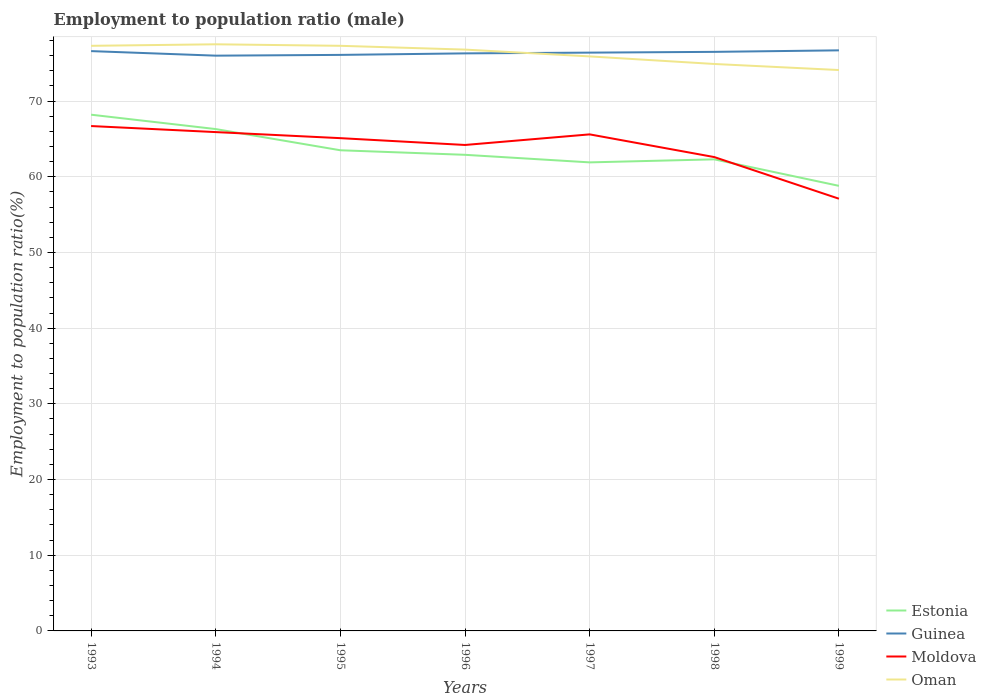Across all years, what is the maximum employment to population ratio in Oman?
Your answer should be compact. 74.1. What is the total employment to population ratio in Moldova in the graph?
Provide a short and direct response. 7.1. What is the difference between the highest and the second highest employment to population ratio in Guinea?
Your answer should be compact. 0.7. What is the difference between the highest and the lowest employment to population ratio in Oman?
Ensure brevity in your answer.  4. How many years are there in the graph?
Your response must be concise. 7. Where does the legend appear in the graph?
Your answer should be compact. Bottom right. How many legend labels are there?
Offer a terse response. 4. What is the title of the graph?
Your answer should be compact. Employment to population ratio (male). Does "Latvia" appear as one of the legend labels in the graph?
Give a very brief answer. No. What is the Employment to population ratio(%) in Estonia in 1993?
Provide a succinct answer. 68.2. What is the Employment to population ratio(%) of Guinea in 1993?
Your response must be concise. 76.6. What is the Employment to population ratio(%) of Moldova in 1993?
Give a very brief answer. 66.7. What is the Employment to population ratio(%) in Oman in 1993?
Offer a terse response. 77.3. What is the Employment to population ratio(%) in Estonia in 1994?
Ensure brevity in your answer.  66.3. What is the Employment to population ratio(%) of Moldova in 1994?
Provide a short and direct response. 65.9. What is the Employment to population ratio(%) of Oman in 1994?
Offer a very short reply. 77.5. What is the Employment to population ratio(%) of Estonia in 1995?
Make the answer very short. 63.5. What is the Employment to population ratio(%) in Guinea in 1995?
Provide a succinct answer. 76.1. What is the Employment to population ratio(%) of Moldova in 1995?
Give a very brief answer. 65.1. What is the Employment to population ratio(%) in Oman in 1995?
Give a very brief answer. 77.3. What is the Employment to population ratio(%) of Estonia in 1996?
Make the answer very short. 62.9. What is the Employment to population ratio(%) of Guinea in 1996?
Make the answer very short. 76.3. What is the Employment to population ratio(%) of Moldova in 1996?
Your answer should be very brief. 64.2. What is the Employment to population ratio(%) in Oman in 1996?
Your response must be concise. 76.8. What is the Employment to population ratio(%) of Estonia in 1997?
Keep it short and to the point. 61.9. What is the Employment to population ratio(%) of Guinea in 1997?
Your response must be concise. 76.4. What is the Employment to population ratio(%) in Moldova in 1997?
Give a very brief answer. 65.6. What is the Employment to population ratio(%) of Oman in 1997?
Your response must be concise. 75.9. What is the Employment to population ratio(%) of Estonia in 1998?
Offer a very short reply. 62.3. What is the Employment to population ratio(%) of Guinea in 1998?
Give a very brief answer. 76.5. What is the Employment to population ratio(%) in Moldova in 1998?
Your response must be concise. 62.6. What is the Employment to population ratio(%) in Oman in 1998?
Ensure brevity in your answer.  74.9. What is the Employment to population ratio(%) of Estonia in 1999?
Make the answer very short. 58.8. What is the Employment to population ratio(%) of Guinea in 1999?
Offer a very short reply. 76.7. What is the Employment to population ratio(%) of Moldova in 1999?
Keep it short and to the point. 57.1. What is the Employment to population ratio(%) of Oman in 1999?
Offer a terse response. 74.1. Across all years, what is the maximum Employment to population ratio(%) in Estonia?
Keep it short and to the point. 68.2. Across all years, what is the maximum Employment to population ratio(%) in Guinea?
Provide a succinct answer. 76.7. Across all years, what is the maximum Employment to population ratio(%) of Moldova?
Make the answer very short. 66.7. Across all years, what is the maximum Employment to population ratio(%) in Oman?
Keep it short and to the point. 77.5. Across all years, what is the minimum Employment to population ratio(%) of Estonia?
Offer a very short reply. 58.8. Across all years, what is the minimum Employment to population ratio(%) in Guinea?
Offer a very short reply. 76. Across all years, what is the minimum Employment to population ratio(%) of Moldova?
Make the answer very short. 57.1. Across all years, what is the minimum Employment to population ratio(%) in Oman?
Your answer should be very brief. 74.1. What is the total Employment to population ratio(%) in Estonia in the graph?
Make the answer very short. 443.9. What is the total Employment to population ratio(%) in Guinea in the graph?
Offer a very short reply. 534.6. What is the total Employment to population ratio(%) in Moldova in the graph?
Ensure brevity in your answer.  447.2. What is the total Employment to population ratio(%) of Oman in the graph?
Offer a terse response. 533.8. What is the difference between the Employment to population ratio(%) in Guinea in 1993 and that in 1994?
Offer a very short reply. 0.6. What is the difference between the Employment to population ratio(%) of Estonia in 1993 and that in 1995?
Provide a succinct answer. 4.7. What is the difference between the Employment to population ratio(%) in Moldova in 1993 and that in 1995?
Offer a very short reply. 1.6. What is the difference between the Employment to population ratio(%) in Guinea in 1993 and that in 1996?
Your answer should be compact. 0.3. What is the difference between the Employment to population ratio(%) of Oman in 1993 and that in 1997?
Your answer should be very brief. 1.4. What is the difference between the Employment to population ratio(%) of Guinea in 1993 and that in 1998?
Your response must be concise. 0.1. What is the difference between the Employment to population ratio(%) of Guinea in 1993 and that in 1999?
Your response must be concise. -0.1. What is the difference between the Employment to population ratio(%) in Moldova in 1993 and that in 1999?
Offer a terse response. 9.6. What is the difference between the Employment to population ratio(%) in Oman in 1993 and that in 1999?
Offer a terse response. 3.2. What is the difference between the Employment to population ratio(%) in Guinea in 1994 and that in 1995?
Provide a short and direct response. -0.1. What is the difference between the Employment to population ratio(%) of Estonia in 1994 and that in 1996?
Keep it short and to the point. 3.4. What is the difference between the Employment to population ratio(%) in Guinea in 1994 and that in 1996?
Offer a terse response. -0.3. What is the difference between the Employment to population ratio(%) in Estonia in 1994 and that in 1997?
Your answer should be compact. 4.4. What is the difference between the Employment to population ratio(%) in Guinea in 1994 and that in 1998?
Your answer should be very brief. -0.5. What is the difference between the Employment to population ratio(%) in Oman in 1994 and that in 1998?
Your response must be concise. 2.6. What is the difference between the Employment to population ratio(%) of Estonia in 1994 and that in 1999?
Keep it short and to the point. 7.5. What is the difference between the Employment to population ratio(%) of Guinea in 1994 and that in 1999?
Ensure brevity in your answer.  -0.7. What is the difference between the Employment to population ratio(%) of Oman in 1994 and that in 1999?
Keep it short and to the point. 3.4. What is the difference between the Employment to population ratio(%) of Oman in 1995 and that in 1996?
Your response must be concise. 0.5. What is the difference between the Employment to population ratio(%) of Estonia in 1995 and that in 1997?
Keep it short and to the point. 1.6. What is the difference between the Employment to population ratio(%) in Oman in 1995 and that in 1998?
Your response must be concise. 2.4. What is the difference between the Employment to population ratio(%) in Oman in 1995 and that in 1999?
Provide a succinct answer. 3.2. What is the difference between the Employment to population ratio(%) of Estonia in 1996 and that in 1997?
Make the answer very short. 1. What is the difference between the Employment to population ratio(%) in Moldova in 1996 and that in 1997?
Provide a short and direct response. -1.4. What is the difference between the Employment to population ratio(%) of Oman in 1996 and that in 1997?
Offer a terse response. 0.9. What is the difference between the Employment to population ratio(%) of Guinea in 1996 and that in 1998?
Provide a short and direct response. -0.2. What is the difference between the Employment to population ratio(%) of Moldova in 1996 and that in 1998?
Provide a succinct answer. 1.6. What is the difference between the Employment to population ratio(%) of Estonia in 1996 and that in 1999?
Your answer should be very brief. 4.1. What is the difference between the Employment to population ratio(%) of Moldova in 1996 and that in 1999?
Your answer should be very brief. 7.1. What is the difference between the Employment to population ratio(%) in Oman in 1996 and that in 1999?
Keep it short and to the point. 2.7. What is the difference between the Employment to population ratio(%) of Estonia in 1997 and that in 1998?
Make the answer very short. -0.4. What is the difference between the Employment to population ratio(%) in Guinea in 1997 and that in 1998?
Your answer should be very brief. -0.1. What is the difference between the Employment to population ratio(%) of Guinea in 1997 and that in 1999?
Make the answer very short. -0.3. What is the difference between the Employment to population ratio(%) in Estonia in 1993 and the Employment to population ratio(%) in Oman in 1994?
Provide a succinct answer. -9.3. What is the difference between the Employment to population ratio(%) in Guinea in 1993 and the Employment to population ratio(%) in Oman in 1994?
Offer a terse response. -0.9. What is the difference between the Employment to population ratio(%) in Moldova in 1993 and the Employment to population ratio(%) in Oman in 1994?
Offer a very short reply. -10.8. What is the difference between the Employment to population ratio(%) in Guinea in 1993 and the Employment to population ratio(%) in Moldova in 1995?
Provide a succinct answer. 11.5. What is the difference between the Employment to population ratio(%) of Estonia in 1993 and the Employment to population ratio(%) of Guinea in 1996?
Your answer should be compact. -8.1. What is the difference between the Employment to population ratio(%) of Estonia in 1993 and the Employment to population ratio(%) of Oman in 1996?
Offer a terse response. -8.6. What is the difference between the Employment to population ratio(%) in Estonia in 1993 and the Employment to population ratio(%) in Guinea in 1997?
Provide a succinct answer. -8.2. What is the difference between the Employment to population ratio(%) in Estonia in 1993 and the Employment to population ratio(%) in Moldova in 1997?
Offer a very short reply. 2.6. What is the difference between the Employment to population ratio(%) in Guinea in 1993 and the Employment to population ratio(%) in Moldova in 1997?
Your answer should be very brief. 11. What is the difference between the Employment to population ratio(%) of Guinea in 1993 and the Employment to population ratio(%) of Oman in 1997?
Offer a terse response. 0.7. What is the difference between the Employment to population ratio(%) of Moldova in 1993 and the Employment to population ratio(%) of Oman in 1997?
Your answer should be compact. -9.2. What is the difference between the Employment to population ratio(%) in Estonia in 1993 and the Employment to population ratio(%) in Guinea in 1998?
Provide a succinct answer. -8.3. What is the difference between the Employment to population ratio(%) of Guinea in 1993 and the Employment to population ratio(%) of Oman in 1998?
Make the answer very short. 1.7. What is the difference between the Employment to population ratio(%) in Estonia in 1993 and the Employment to population ratio(%) in Guinea in 1999?
Offer a terse response. -8.5. What is the difference between the Employment to population ratio(%) in Estonia in 1993 and the Employment to population ratio(%) in Oman in 1999?
Offer a very short reply. -5.9. What is the difference between the Employment to population ratio(%) in Guinea in 1993 and the Employment to population ratio(%) in Oman in 1999?
Offer a very short reply. 2.5. What is the difference between the Employment to population ratio(%) of Estonia in 1994 and the Employment to population ratio(%) of Moldova in 1995?
Your response must be concise. 1.2. What is the difference between the Employment to population ratio(%) in Estonia in 1994 and the Employment to population ratio(%) in Oman in 1995?
Provide a succinct answer. -11. What is the difference between the Employment to population ratio(%) of Moldova in 1994 and the Employment to population ratio(%) of Oman in 1995?
Provide a succinct answer. -11.4. What is the difference between the Employment to population ratio(%) in Estonia in 1994 and the Employment to population ratio(%) in Moldova in 1996?
Your answer should be compact. 2.1. What is the difference between the Employment to population ratio(%) of Guinea in 1994 and the Employment to population ratio(%) of Moldova in 1996?
Make the answer very short. 11.8. What is the difference between the Employment to population ratio(%) in Guinea in 1994 and the Employment to population ratio(%) in Oman in 1996?
Make the answer very short. -0.8. What is the difference between the Employment to population ratio(%) of Estonia in 1994 and the Employment to population ratio(%) of Moldova in 1997?
Provide a succinct answer. 0.7. What is the difference between the Employment to population ratio(%) in Guinea in 1994 and the Employment to population ratio(%) in Moldova in 1997?
Provide a short and direct response. 10.4. What is the difference between the Employment to population ratio(%) in Guinea in 1994 and the Employment to population ratio(%) in Oman in 1997?
Provide a short and direct response. 0.1. What is the difference between the Employment to population ratio(%) in Moldova in 1994 and the Employment to population ratio(%) in Oman in 1997?
Offer a terse response. -10. What is the difference between the Employment to population ratio(%) in Estonia in 1994 and the Employment to population ratio(%) in Oman in 1998?
Provide a succinct answer. -8.6. What is the difference between the Employment to population ratio(%) of Guinea in 1994 and the Employment to population ratio(%) of Oman in 1998?
Your answer should be very brief. 1.1. What is the difference between the Employment to population ratio(%) in Moldova in 1994 and the Employment to population ratio(%) in Oman in 1998?
Make the answer very short. -9. What is the difference between the Employment to population ratio(%) in Estonia in 1994 and the Employment to population ratio(%) in Guinea in 1999?
Give a very brief answer. -10.4. What is the difference between the Employment to population ratio(%) of Estonia in 1994 and the Employment to population ratio(%) of Moldova in 1999?
Provide a succinct answer. 9.2. What is the difference between the Employment to population ratio(%) of Estonia in 1994 and the Employment to population ratio(%) of Oman in 1999?
Your answer should be compact. -7.8. What is the difference between the Employment to population ratio(%) in Estonia in 1995 and the Employment to population ratio(%) in Guinea in 1996?
Provide a succinct answer. -12.8. What is the difference between the Employment to population ratio(%) in Guinea in 1995 and the Employment to population ratio(%) in Moldova in 1996?
Your response must be concise. 11.9. What is the difference between the Employment to population ratio(%) of Guinea in 1995 and the Employment to population ratio(%) of Oman in 1996?
Provide a short and direct response. -0.7. What is the difference between the Employment to population ratio(%) in Estonia in 1995 and the Employment to population ratio(%) in Guinea in 1997?
Make the answer very short. -12.9. What is the difference between the Employment to population ratio(%) in Guinea in 1995 and the Employment to population ratio(%) in Oman in 1997?
Offer a very short reply. 0.2. What is the difference between the Employment to population ratio(%) in Moldova in 1995 and the Employment to population ratio(%) in Oman in 1997?
Provide a short and direct response. -10.8. What is the difference between the Employment to population ratio(%) of Estonia in 1995 and the Employment to population ratio(%) of Guinea in 1998?
Your answer should be very brief. -13. What is the difference between the Employment to population ratio(%) in Estonia in 1995 and the Employment to population ratio(%) in Oman in 1998?
Ensure brevity in your answer.  -11.4. What is the difference between the Employment to population ratio(%) in Guinea in 1995 and the Employment to population ratio(%) in Moldova in 1998?
Offer a terse response. 13.5. What is the difference between the Employment to population ratio(%) in Estonia in 1995 and the Employment to population ratio(%) in Guinea in 1999?
Keep it short and to the point. -13.2. What is the difference between the Employment to population ratio(%) of Estonia in 1995 and the Employment to population ratio(%) of Moldova in 1999?
Offer a terse response. 6.4. What is the difference between the Employment to population ratio(%) of Estonia in 1995 and the Employment to population ratio(%) of Oman in 1999?
Keep it short and to the point. -10.6. What is the difference between the Employment to population ratio(%) in Guinea in 1995 and the Employment to population ratio(%) in Oman in 1999?
Your answer should be compact. 2. What is the difference between the Employment to population ratio(%) in Moldova in 1995 and the Employment to population ratio(%) in Oman in 1999?
Make the answer very short. -9. What is the difference between the Employment to population ratio(%) in Estonia in 1996 and the Employment to population ratio(%) in Guinea in 1997?
Keep it short and to the point. -13.5. What is the difference between the Employment to population ratio(%) in Estonia in 1996 and the Employment to population ratio(%) in Oman in 1997?
Your answer should be compact. -13. What is the difference between the Employment to population ratio(%) of Guinea in 1996 and the Employment to population ratio(%) of Moldova in 1997?
Your response must be concise. 10.7. What is the difference between the Employment to population ratio(%) of Estonia in 1996 and the Employment to population ratio(%) of Guinea in 1998?
Keep it short and to the point. -13.6. What is the difference between the Employment to population ratio(%) in Estonia in 1996 and the Employment to population ratio(%) in Moldova in 1998?
Make the answer very short. 0.3. What is the difference between the Employment to population ratio(%) in Estonia in 1996 and the Employment to population ratio(%) in Oman in 1998?
Offer a terse response. -12. What is the difference between the Employment to population ratio(%) of Guinea in 1996 and the Employment to population ratio(%) of Oman in 1998?
Provide a succinct answer. 1.4. What is the difference between the Employment to population ratio(%) of Moldova in 1996 and the Employment to population ratio(%) of Oman in 1998?
Offer a very short reply. -10.7. What is the difference between the Employment to population ratio(%) of Guinea in 1996 and the Employment to population ratio(%) of Oman in 1999?
Your answer should be very brief. 2.2. What is the difference between the Employment to population ratio(%) of Estonia in 1997 and the Employment to population ratio(%) of Guinea in 1998?
Ensure brevity in your answer.  -14.6. What is the difference between the Employment to population ratio(%) of Moldova in 1997 and the Employment to population ratio(%) of Oman in 1998?
Offer a very short reply. -9.3. What is the difference between the Employment to population ratio(%) in Estonia in 1997 and the Employment to population ratio(%) in Guinea in 1999?
Ensure brevity in your answer.  -14.8. What is the difference between the Employment to population ratio(%) of Estonia in 1997 and the Employment to population ratio(%) of Moldova in 1999?
Your answer should be compact. 4.8. What is the difference between the Employment to population ratio(%) of Estonia in 1997 and the Employment to population ratio(%) of Oman in 1999?
Make the answer very short. -12.2. What is the difference between the Employment to population ratio(%) in Guinea in 1997 and the Employment to population ratio(%) in Moldova in 1999?
Provide a short and direct response. 19.3. What is the difference between the Employment to population ratio(%) in Estonia in 1998 and the Employment to population ratio(%) in Guinea in 1999?
Your answer should be compact. -14.4. What is the difference between the Employment to population ratio(%) in Estonia in 1998 and the Employment to population ratio(%) in Moldova in 1999?
Offer a very short reply. 5.2. What is the difference between the Employment to population ratio(%) in Estonia in 1998 and the Employment to population ratio(%) in Oman in 1999?
Ensure brevity in your answer.  -11.8. What is the difference between the Employment to population ratio(%) in Moldova in 1998 and the Employment to population ratio(%) in Oman in 1999?
Provide a short and direct response. -11.5. What is the average Employment to population ratio(%) in Estonia per year?
Ensure brevity in your answer.  63.41. What is the average Employment to population ratio(%) of Guinea per year?
Your answer should be compact. 76.37. What is the average Employment to population ratio(%) in Moldova per year?
Provide a short and direct response. 63.89. What is the average Employment to population ratio(%) of Oman per year?
Provide a short and direct response. 76.26. In the year 1993, what is the difference between the Employment to population ratio(%) in Estonia and Employment to population ratio(%) in Moldova?
Ensure brevity in your answer.  1.5. In the year 1993, what is the difference between the Employment to population ratio(%) in Guinea and Employment to population ratio(%) in Moldova?
Your answer should be compact. 9.9. In the year 1994, what is the difference between the Employment to population ratio(%) of Estonia and Employment to population ratio(%) of Guinea?
Your answer should be compact. -9.7. In the year 1994, what is the difference between the Employment to population ratio(%) of Estonia and Employment to population ratio(%) of Moldova?
Offer a terse response. 0.4. In the year 1994, what is the difference between the Employment to population ratio(%) in Estonia and Employment to population ratio(%) in Oman?
Your answer should be compact. -11.2. In the year 1994, what is the difference between the Employment to population ratio(%) in Moldova and Employment to population ratio(%) in Oman?
Provide a short and direct response. -11.6. In the year 1995, what is the difference between the Employment to population ratio(%) of Estonia and Employment to population ratio(%) of Moldova?
Make the answer very short. -1.6. In the year 1995, what is the difference between the Employment to population ratio(%) in Estonia and Employment to population ratio(%) in Oman?
Keep it short and to the point. -13.8. In the year 1995, what is the difference between the Employment to population ratio(%) in Moldova and Employment to population ratio(%) in Oman?
Offer a terse response. -12.2. In the year 1996, what is the difference between the Employment to population ratio(%) in Estonia and Employment to population ratio(%) in Oman?
Ensure brevity in your answer.  -13.9. In the year 1997, what is the difference between the Employment to population ratio(%) of Estonia and Employment to population ratio(%) of Moldova?
Your response must be concise. -3.7. In the year 1997, what is the difference between the Employment to population ratio(%) of Guinea and Employment to population ratio(%) of Oman?
Keep it short and to the point. 0.5. In the year 1997, what is the difference between the Employment to population ratio(%) in Moldova and Employment to population ratio(%) in Oman?
Give a very brief answer. -10.3. In the year 1998, what is the difference between the Employment to population ratio(%) in Estonia and Employment to population ratio(%) in Guinea?
Your answer should be very brief. -14.2. In the year 1998, what is the difference between the Employment to population ratio(%) in Guinea and Employment to population ratio(%) in Moldova?
Your response must be concise. 13.9. In the year 1999, what is the difference between the Employment to population ratio(%) of Estonia and Employment to population ratio(%) of Guinea?
Your answer should be compact. -17.9. In the year 1999, what is the difference between the Employment to population ratio(%) in Estonia and Employment to population ratio(%) in Oman?
Your answer should be very brief. -15.3. In the year 1999, what is the difference between the Employment to population ratio(%) in Guinea and Employment to population ratio(%) in Moldova?
Provide a short and direct response. 19.6. In the year 1999, what is the difference between the Employment to population ratio(%) in Guinea and Employment to population ratio(%) in Oman?
Offer a terse response. 2.6. What is the ratio of the Employment to population ratio(%) of Estonia in 1993 to that in 1994?
Your answer should be very brief. 1.03. What is the ratio of the Employment to population ratio(%) of Guinea in 1993 to that in 1994?
Make the answer very short. 1.01. What is the ratio of the Employment to population ratio(%) in Moldova in 1993 to that in 1994?
Make the answer very short. 1.01. What is the ratio of the Employment to population ratio(%) of Estonia in 1993 to that in 1995?
Ensure brevity in your answer.  1.07. What is the ratio of the Employment to population ratio(%) in Guinea in 1993 to that in 1995?
Make the answer very short. 1.01. What is the ratio of the Employment to population ratio(%) of Moldova in 1993 to that in 1995?
Give a very brief answer. 1.02. What is the ratio of the Employment to population ratio(%) in Oman in 1993 to that in 1995?
Provide a short and direct response. 1. What is the ratio of the Employment to population ratio(%) in Estonia in 1993 to that in 1996?
Provide a short and direct response. 1.08. What is the ratio of the Employment to population ratio(%) of Guinea in 1993 to that in 1996?
Make the answer very short. 1. What is the ratio of the Employment to population ratio(%) in Moldova in 1993 to that in 1996?
Make the answer very short. 1.04. What is the ratio of the Employment to population ratio(%) of Estonia in 1993 to that in 1997?
Give a very brief answer. 1.1. What is the ratio of the Employment to population ratio(%) of Guinea in 1993 to that in 1997?
Offer a terse response. 1. What is the ratio of the Employment to population ratio(%) in Moldova in 1993 to that in 1997?
Your response must be concise. 1.02. What is the ratio of the Employment to population ratio(%) in Oman in 1993 to that in 1997?
Make the answer very short. 1.02. What is the ratio of the Employment to population ratio(%) in Estonia in 1993 to that in 1998?
Keep it short and to the point. 1.09. What is the ratio of the Employment to population ratio(%) in Moldova in 1993 to that in 1998?
Provide a short and direct response. 1.07. What is the ratio of the Employment to population ratio(%) in Oman in 1993 to that in 1998?
Provide a short and direct response. 1.03. What is the ratio of the Employment to population ratio(%) of Estonia in 1993 to that in 1999?
Make the answer very short. 1.16. What is the ratio of the Employment to population ratio(%) of Guinea in 1993 to that in 1999?
Your answer should be compact. 1. What is the ratio of the Employment to population ratio(%) in Moldova in 1993 to that in 1999?
Give a very brief answer. 1.17. What is the ratio of the Employment to population ratio(%) in Oman in 1993 to that in 1999?
Keep it short and to the point. 1.04. What is the ratio of the Employment to population ratio(%) of Estonia in 1994 to that in 1995?
Your response must be concise. 1.04. What is the ratio of the Employment to population ratio(%) in Moldova in 1994 to that in 1995?
Your response must be concise. 1.01. What is the ratio of the Employment to population ratio(%) in Estonia in 1994 to that in 1996?
Your response must be concise. 1.05. What is the ratio of the Employment to population ratio(%) in Guinea in 1994 to that in 1996?
Ensure brevity in your answer.  1. What is the ratio of the Employment to population ratio(%) in Moldova in 1994 to that in 1996?
Keep it short and to the point. 1.03. What is the ratio of the Employment to population ratio(%) of Oman in 1994 to that in 1996?
Make the answer very short. 1.01. What is the ratio of the Employment to population ratio(%) of Estonia in 1994 to that in 1997?
Your answer should be compact. 1.07. What is the ratio of the Employment to population ratio(%) of Guinea in 1994 to that in 1997?
Make the answer very short. 0.99. What is the ratio of the Employment to population ratio(%) in Oman in 1994 to that in 1997?
Give a very brief answer. 1.02. What is the ratio of the Employment to population ratio(%) of Estonia in 1994 to that in 1998?
Provide a short and direct response. 1.06. What is the ratio of the Employment to population ratio(%) of Moldova in 1994 to that in 1998?
Keep it short and to the point. 1.05. What is the ratio of the Employment to population ratio(%) in Oman in 1994 to that in 1998?
Offer a very short reply. 1.03. What is the ratio of the Employment to population ratio(%) in Estonia in 1994 to that in 1999?
Ensure brevity in your answer.  1.13. What is the ratio of the Employment to population ratio(%) of Guinea in 1994 to that in 1999?
Offer a very short reply. 0.99. What is the ratio of the Employment to population ratio(%) of Moldova in 1994 to that in 1999?
Offer a very short reply. 1.15. What is the ratio of the Employment to population ratio(%) in Oman in 1994 to that in 1999?
Ensure brevity in your answer.  1.05. What is the ratio of the Employment to population ratio(%) in Estonia in 1995 to that in 1996?
Keep it short and to the point. 1.01. What is the ratio of the Employment to population ratio(%) of Guinea in 1995 to that in 1996?
Give a very brief answer. 1. What is the ratio of the Employment to population ratio(%) of Oman in 1995 to that in 1996?
Offer a terse response. 1.01. What is the ratio of the Employment to population ratio(%) of Estonia in 1995 to that in 1997?
Ensure brevity in your answer.  1.03. What is the ratio of the Employment to population ratio(%) in Moldova in 1995 to that in 1997?
Your answer should be compact. 0.99. What is the ratio of the Employment to population ratio(%) in Oman in 1995 to that in 1997?
Ensure brevity in your answer.  1.02. What is the ratio of the Employment to population ratio(%) in Estonia in 1995 to that in 1998?
Your answer should be very brief. 1.02. What is the ratio of the Employment to population ratio(%) of Moldova in 1995 to that in 1998?
Offer a very short reply. 1.04. What is the ratio of the Employment to population ratio(%) in Oman in 1995 to that in 1998?
Offer a very short reply. 1.03. What is the ratio of the Employment to population ratio(%) of Estonia in 1995 to that in 1999?
Offer a very short reply. 1.08. What is the ratio of the Employment to population ratio(%) of Moldova in 1995 to that in 1999?
Your answer should be compact. 1.14. What is the ratio of the Employment to population ratio(%) in Oman in 1995 to that in 1999?
Provide a succinct answer. 1.04. What is the ratio of the Employment to population ratio(%) of Estonia in 1996 to that in 1997?
Offer a very short reply. 1.02. What is the ratio of the Employment to population ratio(%) of Guinea in 1996 to that in 1997?
Provide a succinct answer. 1. What is the ratio of the Employment to population ratio(%) in Moldova in 1996 to that in 1997?
Ensure brevity in your answer.  0.98. What is the ratio of the Employment to population ratio(%) in Oman in 1996 to that in 1997?
Your answer should be very brief. 1.01. What is the ratio of the Employment to population ratio(%) in Estonia in 1996 to that in 1998?
Your answer should be very brief. 1.01. What is the ratio of the Employment to population ratio(%) of Guinea in 1996 to that in 1998?
Offer a terse response. 1. What is the ratio of the Employment to population ratio(%) in Moldova in 1996 to that in 1998?
Your answer should be compact. 1.03. What is the ratio of the Employment to population ratio(%) of Oman in 1996 to that in 1998?
Provide a short and direct response. 1.03. What is the ratio of the Employment to population ratio(%) in Estonia in 1996 to that in 1999?
Your response must be concise. 1.07. What is the ratio of the Employment to population ratio(%) of Moldova in 1996 to that in 1999?
Your answer should be compact. 1.12. What is the ratio of the Employment to population ratio(%) of Oman in 1996 to that in 1999?
Give a very brief answer. 1.04. What is the ratio of the Employment to population ratio(%) of Estonia in 1997 to that in 1998?
Offer a very short reply. 0.99. What is the ratio of the Employment to population ratio(%) in Guinea in 1997 to that in 1998?
Provide a succinct answer. 1. What is the ratio of the Employment to population ratio(%) in Moldova in 1997 to that in 1998?
Ensure brevity in your answer.  1.05. What is the ratio of the Employment to population ratio(%) of Oman in 1997 to that in 1998?
Provide a short and direct response. 1.01. What is the ratio of the Employment to population ratio(%) in Estonia in 1997 to that in 1999?
Your response must be concise. 1.05. What is the ratio of the Employment to population ratio(%) of Guinea in 1997 to that in 1999?
Provide a succinct answer. 1. What is the ratio of the Employment to population ratio(%) in Moldova in 1997 to that in 1999?
Give a very brief answer. 1.15. What is the ratio of the Employment to population ratio(%) of Oman in 1997 to that in 1999?
Give a very brief answer. 1.02. What is the ratio of the Employment to population ratio(%) in Estonia in 1998 to that in 1999?
Your answer should be very brief. 1.06. What is the ratio of the Employment to population ratio(%) in Guinea in 1998 to that in 1999?
Offer a terse response. 1. What is the ratio of the Employment to population ratio(%) of Moldova in 1998 to that in 1999?
Your response must be concise. 1.1. What is the ratio of the Employment to population ratio(%) in Oman in 1998 to that in 1999?
Your answer should be very brief. 1.01. What is the difference between the highest and the second highest Employment to population ratio(%) in Estonia?
Offer a very short reply. 1.9. What is the difference between the highest and the second highest Employment to population ratio(%) of Moldova?
Your answer should be very brief. 0.8. What is the difference between the highest and the second highest Employment to population ratio(%) of Oman?
Keep it short and to the point. 0.2. What is the difference between the highest and the lowest Employment to population ratio(%) of Estonia?
Your answer should be very brief. 9.4. 